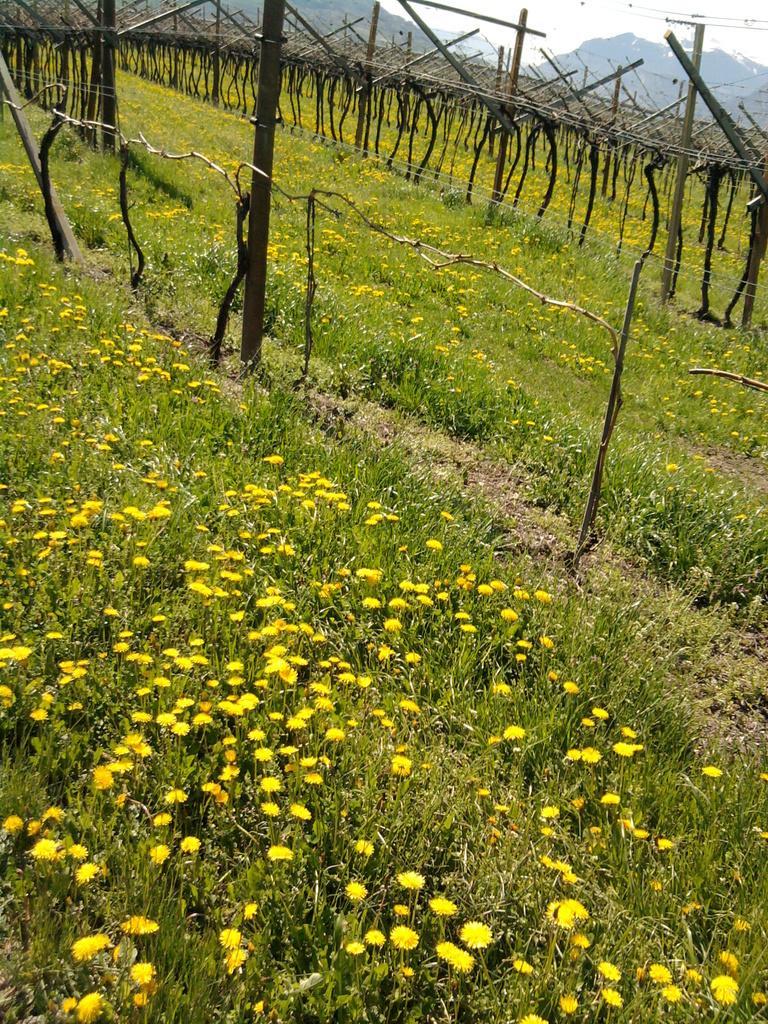Could you give a brief overview of what you see in this image? In this picture there is a garden and it is filled with the yellow flowers. In between the plants, there are wooden poles. In the background, there are hills and sky. 